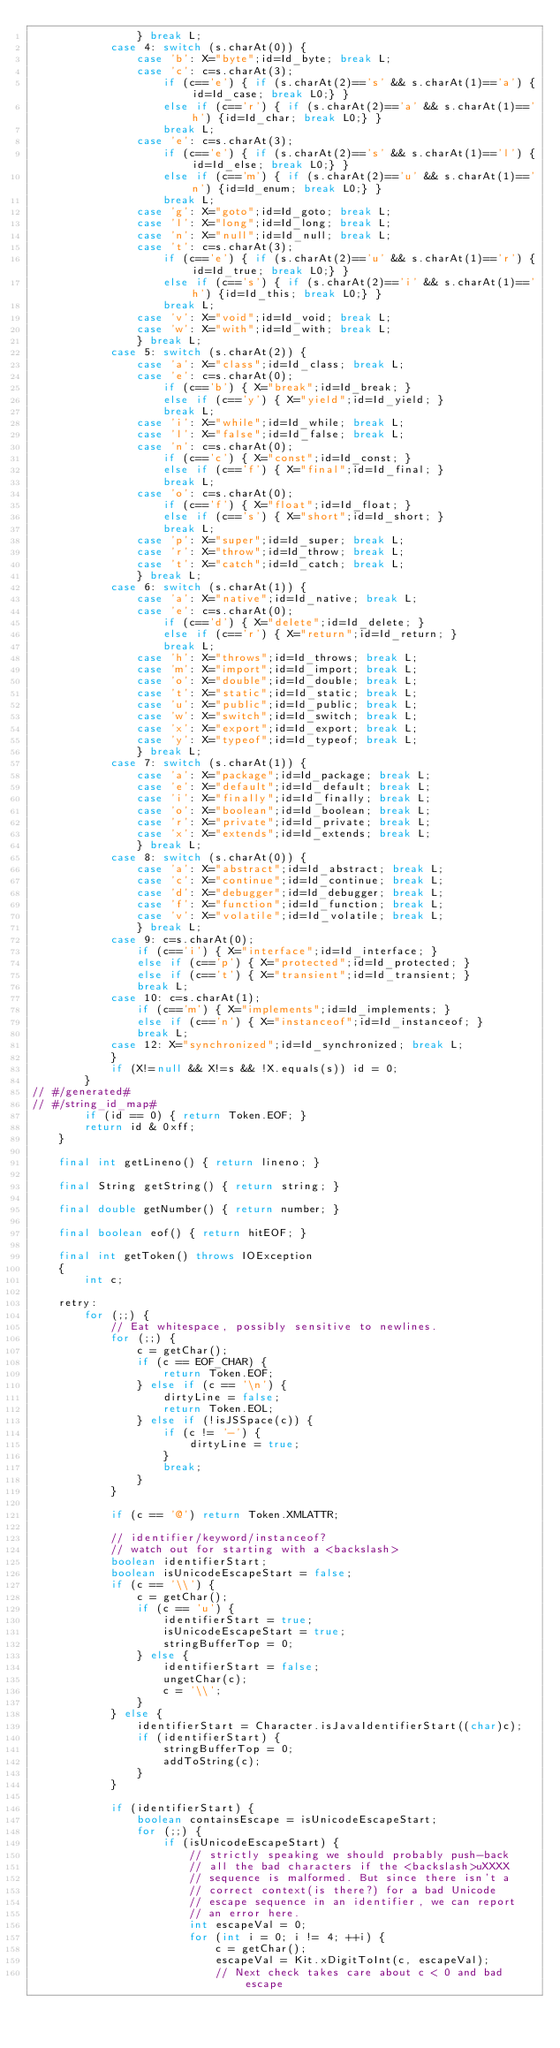Convert code to text. <code><loc_0><loc_0><loc_500><loc_500><_Java_>                } break L;
            case 4: switch (s.charAt(0)) {
                case 'b': X="byte";id=Id_byte; break L;
                case 'c': c=s.charAt(3);
                    if (c=='e') { if (s.charAt(2)=='s' && s.charAt(1)=='a') {id=Id_case; break L0;} }
                    else if (c=='r') { if (s.charAt(2)=='a' && s.charAt(1)=='h') {id=Id_char; break L0;} }
                    break L;
                case 'e': c=s.charAt(3);
                    if (c=='e') { if (s.charAt(2)=='s' && s.charAt(1)=='l') {id=Id_else; break L0;} }
                    else if (c=='m') { if (s.charAt(2)=='u' && s.charAt(1)=='n') {id=Id_enum; break L0;} }
                    break L;
                case 'g': X="goto";id=Id_goto; break L;
                case 'l': X="long";id=Id_long; break L;
                case 'n': X="null";id=Id_null; break L;
                case 't': c=s.charAt(3);
                    if (c=='e') { if (s.charAt(2)=='u' && s.charAt(1)=='r') {id=Id_true; break L0;} }
                    else if (c=='s') { if (s.charAt(2)=='i' && s.charAt(1)=='h') {id=Id_this; break L0;} }
                    break L;
                case 'v': X="void";id=Id_void; break L;
                case 'w': X="with";id=Id_with; break L;
                } break L;
            case 5: switch (s.charAt(2)) {
                case 'a': X="class";id=Id_class; break L;
                case 'e': c=s.charAt(0);
                    if (c=='b') { X="break";id=Id_break; }
                    else if (c=='y') { X="yield";id=Id_yield; }
                    break L;
                case 'i': X="while";id=Id_while; break L;
                case 'l': X="false";id=Id_false; break L;
                case 'n': c=s.charAt(0);
                    if (c=='c') { X="const";id=Id_const; }
                    else if (c=='f') { X="final";id=Id_final; }
                    break L;
                case 'o': c=s.charAt(0);
                    if (c=='f') { X="float";id=Id_float; }
                    else if (c=='s') { X="short";id=Id_short; }
                    break L;
                case 'p': X="super";id=Id_super; break L;
                case 'r': X="throw";id=Id_throw; break L;
                case 't': X="catch";id=Id_catch; break L;
                } break L;
            case 6: switch (s.charAt(1)) {
                case 'a': X="native";id=Id_native; break L;
                case 'e': c=s.charAt(0);
                    if (c=='d') { X="delete";id=Id_delete; }
                    else if (c=='r') { X="return";id=Id_return; }
                    break L;
                case 'h': X="throws";id=Id_throws; break L;
                case 'm': X="import";id=Id_import; break L;
                case 'o': X="double";id=Id_double; break L;
                case 't': X="static";id=Id_static; break L;
                case 'u': X="public";id=Id_public; break L;
                case 'w': X="switch";id=Id_switch; break L;
                case 'x': X="export";id=Id_export; break L;
                case 'y': X="typeof";id=Id_typeof; break L;
                } break L;
            case 7: switch (s.charAt(1)) {
                case 'a': X="package";id=Id_package; break L;
                case 'e': X="default";id=Id_default; break L;
                case 'i': X="finally";id=Id_finally; break L;
                case 'o': X="boolean";id=Id_boolean; break L;
                case 'r': X="private";id=Id_private; break L;
                case 'x': X="extends";id=Id_extends; break L;
                } break L;
            case 8: switch (s.charAt(0)) {
                case 'a': X="abstract";id=Id_abstract; break L;
                case 'c': X="continue";id=Id_continue; break L;
                case 'd': X="debugger";id=Id_debugger; break L;
                case 'f': X="function";id=Id_function; break L;
                case 'v': X="volatile";id=Id_volatile; break L;
                } break L;
            case 9: c=s.charAt(0);
                if (c=='i') { X="interface";id=Id_interface; }
                else if (c=='p') { X="protected";id=Id_protected; }
                else if (c=='t') { X="transient";id=Id_transient; }
                break L;
            case 10: c=s.charAt(1);
                if (c=='m') { X="implements";id=Id_implements; }
                else if (c=='n') { X="instanceof";id=Id_instanceof; }
                break L;
            case 12: X="synchronized";id=Id_synchronized; break L;
            }
            if (X!=null && X!=s && !X.equals(s)) id = 0;
        }
// #/generated#
// #/string_id_map#
        if (id == 0) { return Token.EOF; }
        return id & 0xff;
    }

    final int getLineno() { return lineno; }

    final String getString() { return string; }

    final double getNumber() { return number; }

    final boolean eof() { return hitEOF; }

    final int getToken() throws IOException
    {
        int c;

    retry:
        for (;;) {
            // Eat whitespace, possibly sensitive to newlines.
            for (;;) {
                c = getChar();
                if (c == EOF_CHAR) {
                    return Token.EOF;
                } else if (c == '\n') {
                    dirtyLine = false;
                    return Token.EOL;
                } else if (!isJSSpace(c)) {
                    if (c != '-') {
                        dirtyLine = true;
                    }
                    break;
                }
            }

            if (c == '@') return Token.XMLATTR;

            // identifier/keyword/instanceof?
            // watch out for starting with a <backslash>
            boolean identifierStart;
            boolean isUnicodeEscapeStart = false;
            if (c == '\\') {
                c = getChar();
                if (c == 'u') {
                    identifierStart = true;
                    isUnicodeEscapeStart = true;
                    stringBufferTop = 0;
                } else {
                    identifierStart = false;
                    ungetChar(c);
                    c = '\\';
                }
            } else {
                identifierStart = Character.isJavaIdentifierStart((char)c);
                if (identifierStart) {
                    stringBufferTop = 0;
                    addToString(c);
                }
            }

            if (identifierStart) {
                boolean containsEscape = isUnicodeEscapeStart;
                for (;;) {
                    if (isUnicodeEscapeStart) {
                        // strictly speaking we should probably push-back
                        // all the bad characters if the <backslash>uXXXX
                        // sequence is malformed. But since there isn't a
                        // correct context(is there?) for a bad Unicode
                        // escape sequence in an identifier, we can report
                        // an error here.
                        int escapeVal = 0;
                        for (int i = 0; i != 4; ++i) {
                            c = getChar();
                            escapeVal = Kit.xDigitToInt(c, escapeVal);
                            // Next check takes care about c < 0 and bad escape</code> 